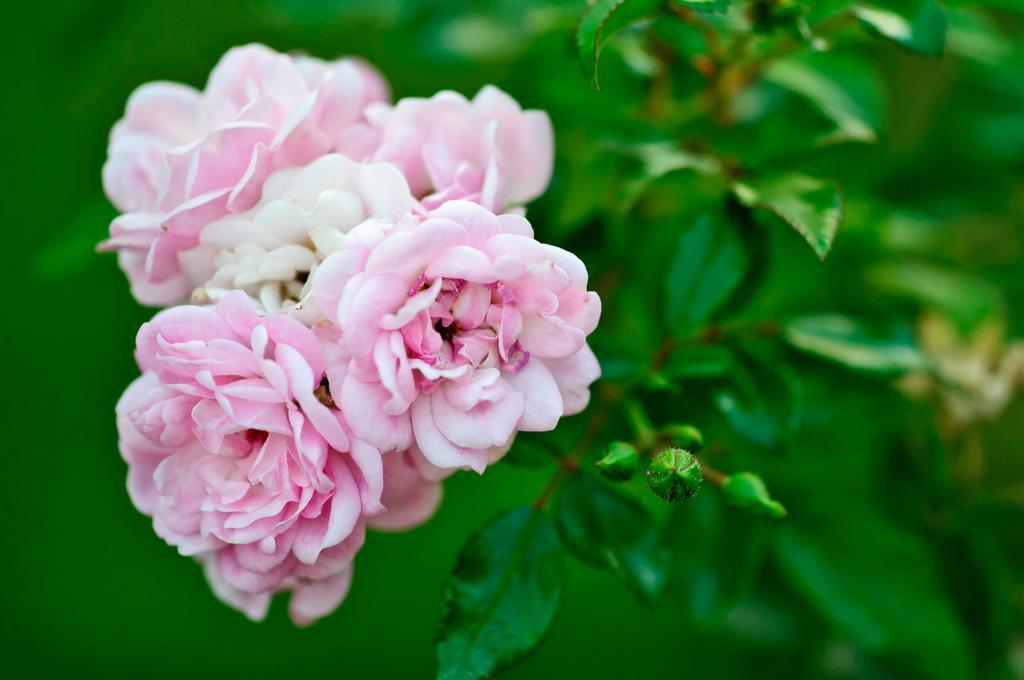Could you give a brief overview of what you see in this image? In this image we can see flowers and buds to the plant. 